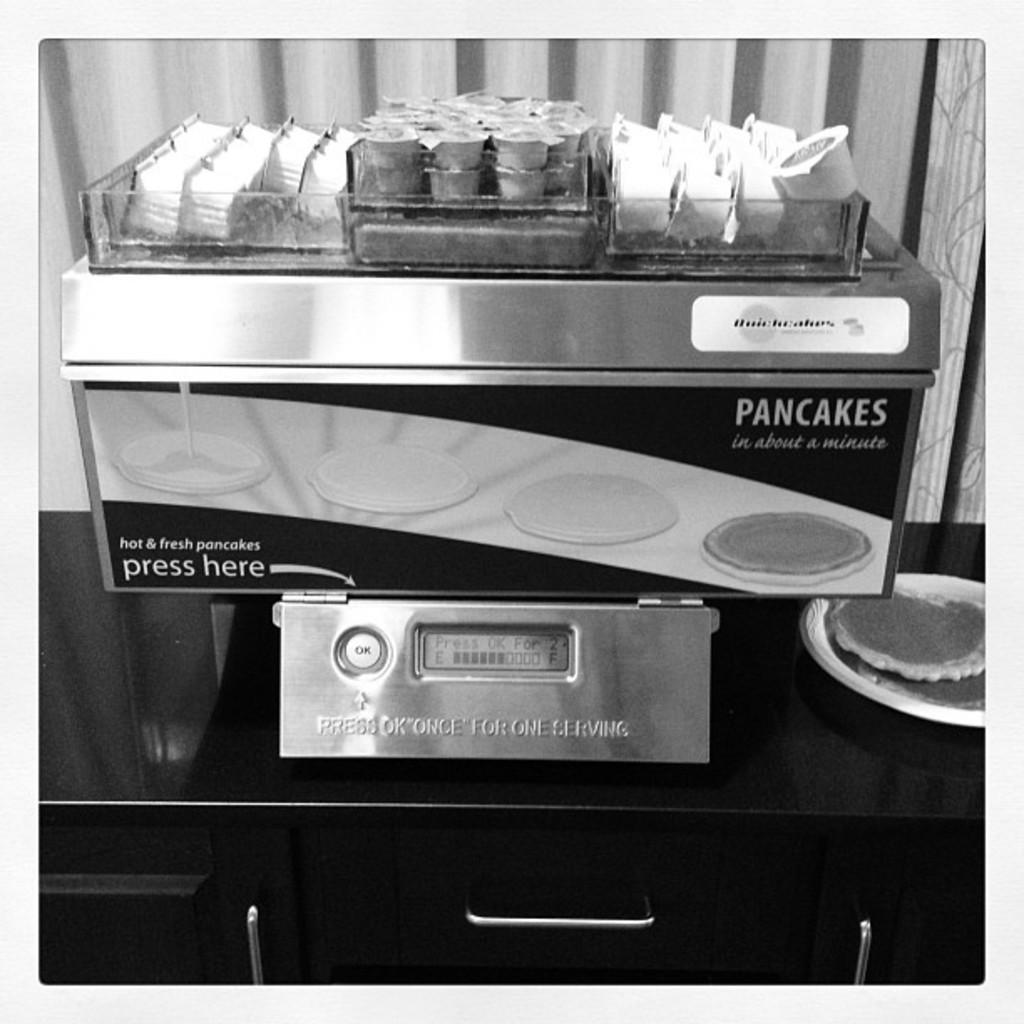<image>
Create a compact narrative representing the image presented. A person should press the "ok" button one time for a single serving of pancakes. 